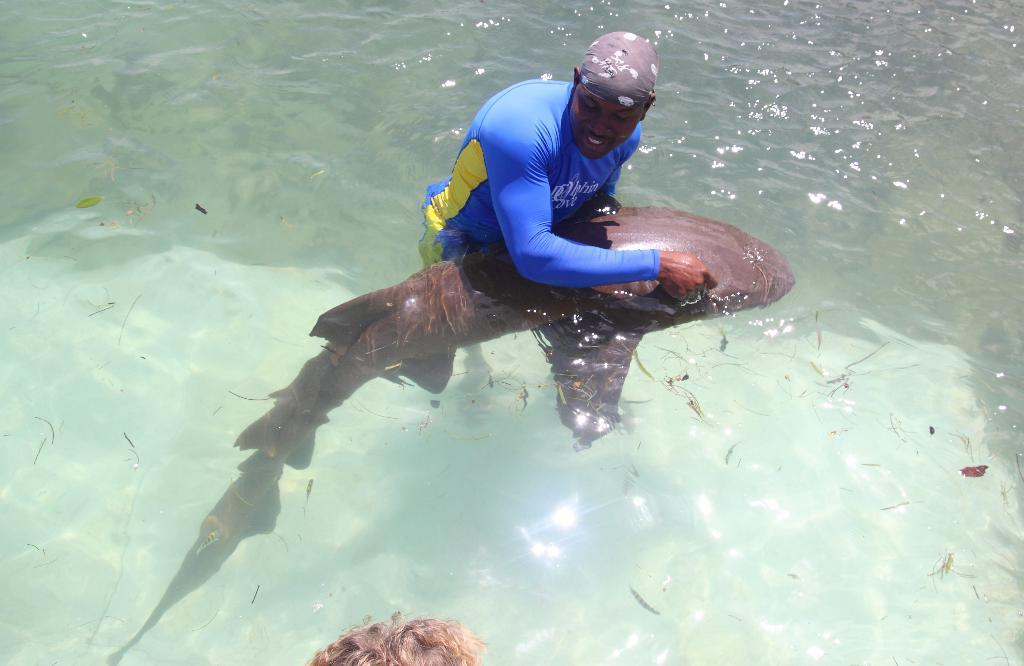What is the main feature of the image? There is a water body in the image. What is located in the middle of the image? There is a person and a fish in the middle of the image. Can you describe the person's hair in the image? A person's hair is visible at the bottom of the image. How does the person walk on the water in the image? The person does not walk on the water in the image; they are in the water with a fish. 